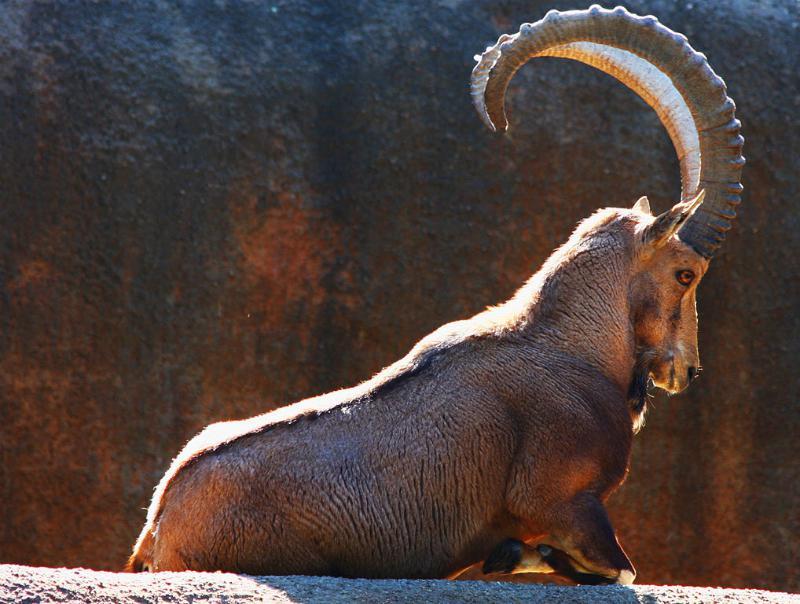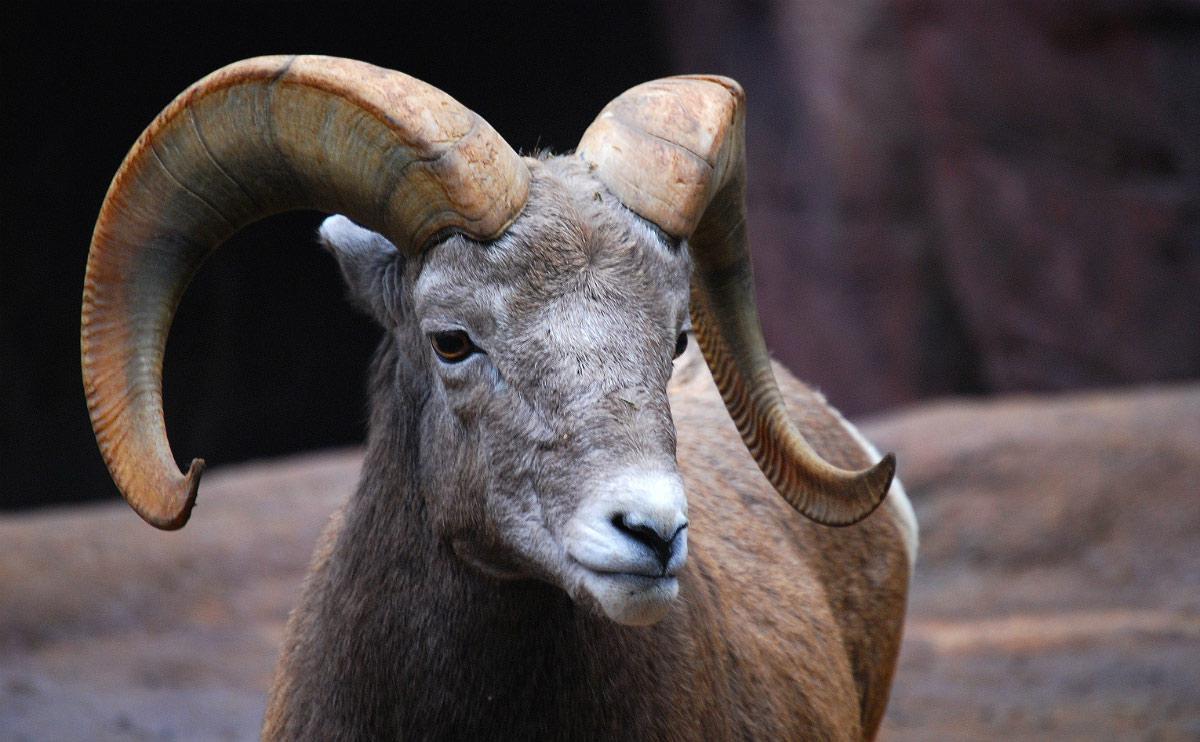The first image is the image on the left, the second image is the image on the right. For the images shown, is this caption "The animal in the image on the left is looking into the camera." true? Answer yes or no. No. 